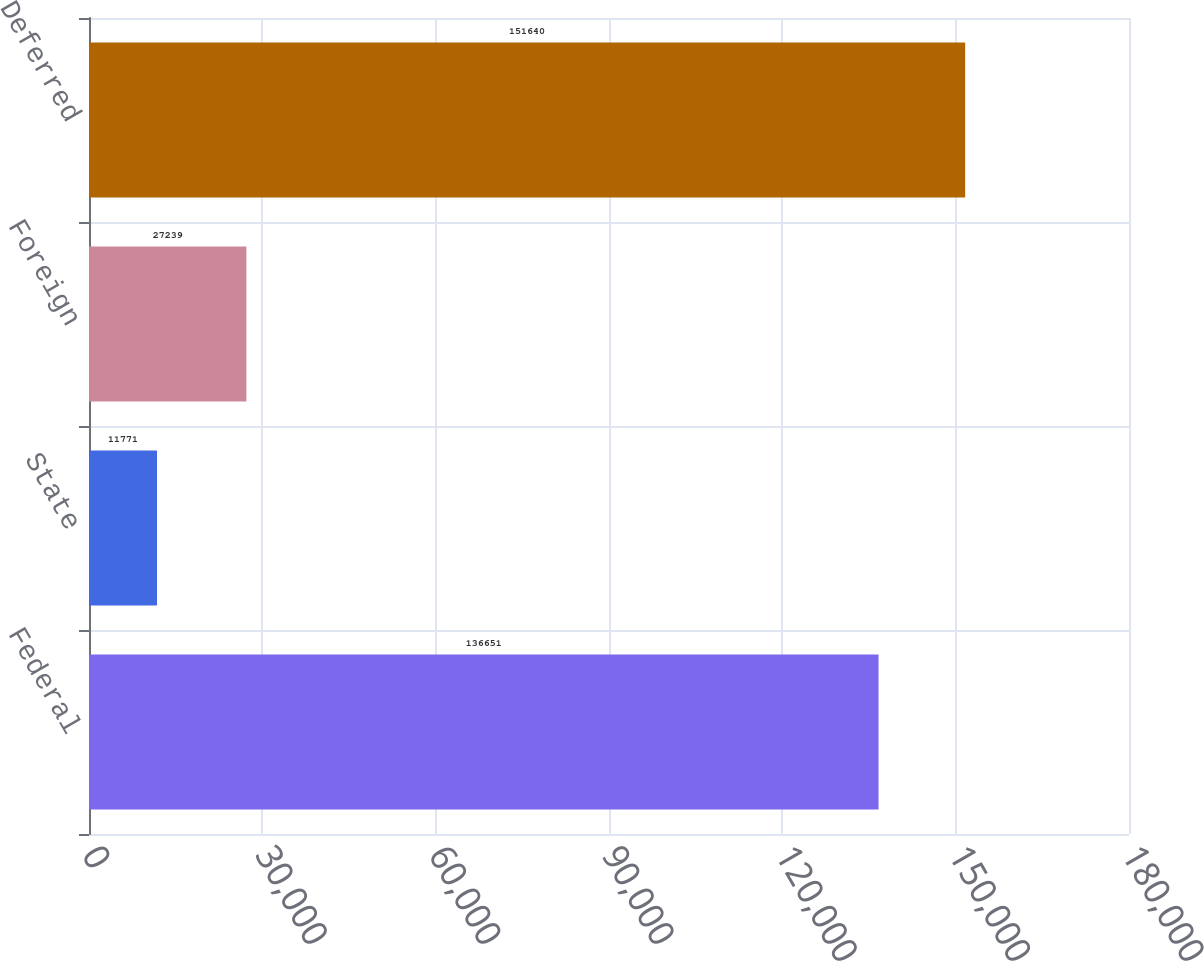Convert chart. <chart><loc_0><loc_0><loc_500><loc_500><bar_chart><fcel>Federal<fcel>State<fcel>Foreign<fcel>Deferred<nl><fcel>136651<fcel>11771<fcel>27239<fcel>151640<nl></chart> 